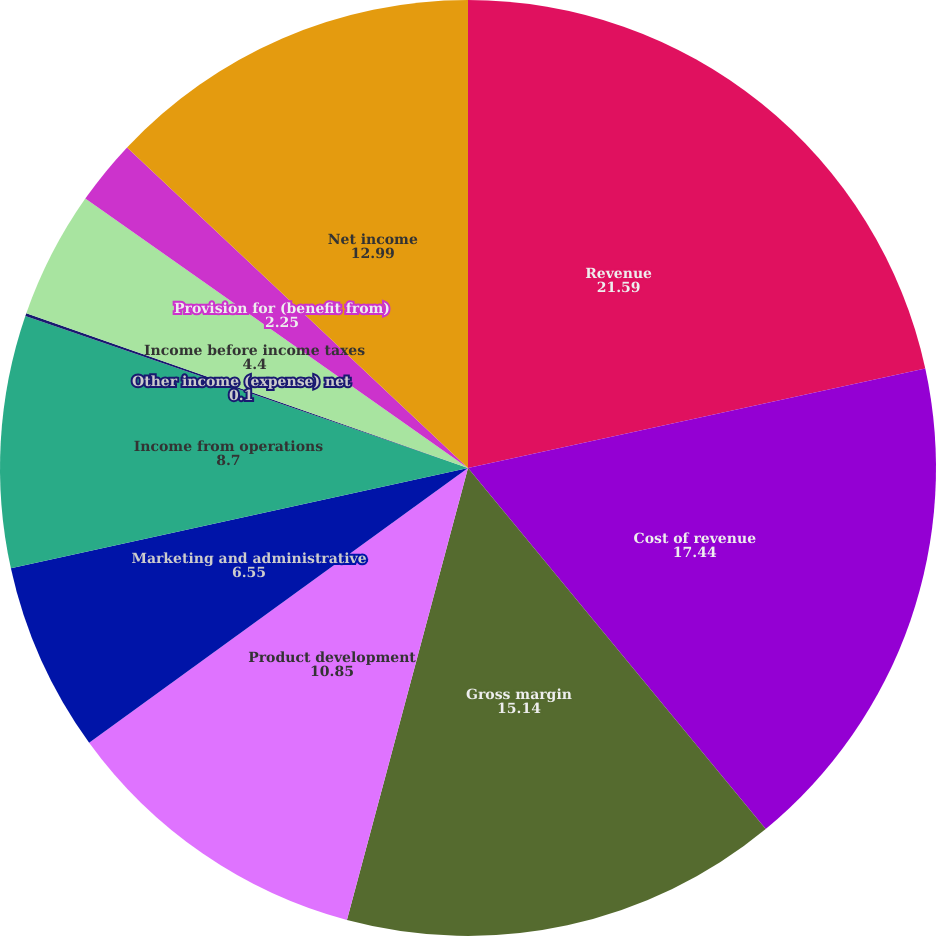<chart> <loc_0><loc_0><loc_500><loc_500><pie_chart><fcel>Revenue<fcel>Cost of revenue<fcel>Gross margin<fcel>Product development<fcel>Marketing and administrative<fcel>Income from operations<fcel>Other income (expense) net<fcel>Income before income taxes<fcel>Provision for (benefit from)<fcel>Net income<nl><fcel>21.59%<fcel>17.44%<fcel>15.14%<fcel>10.85%<fcel>6.55%<fcel>8.7%<fcel>0.1%<fcel>4.4%<fcel>2.25%<fcel>12.99%<nl></chart> 